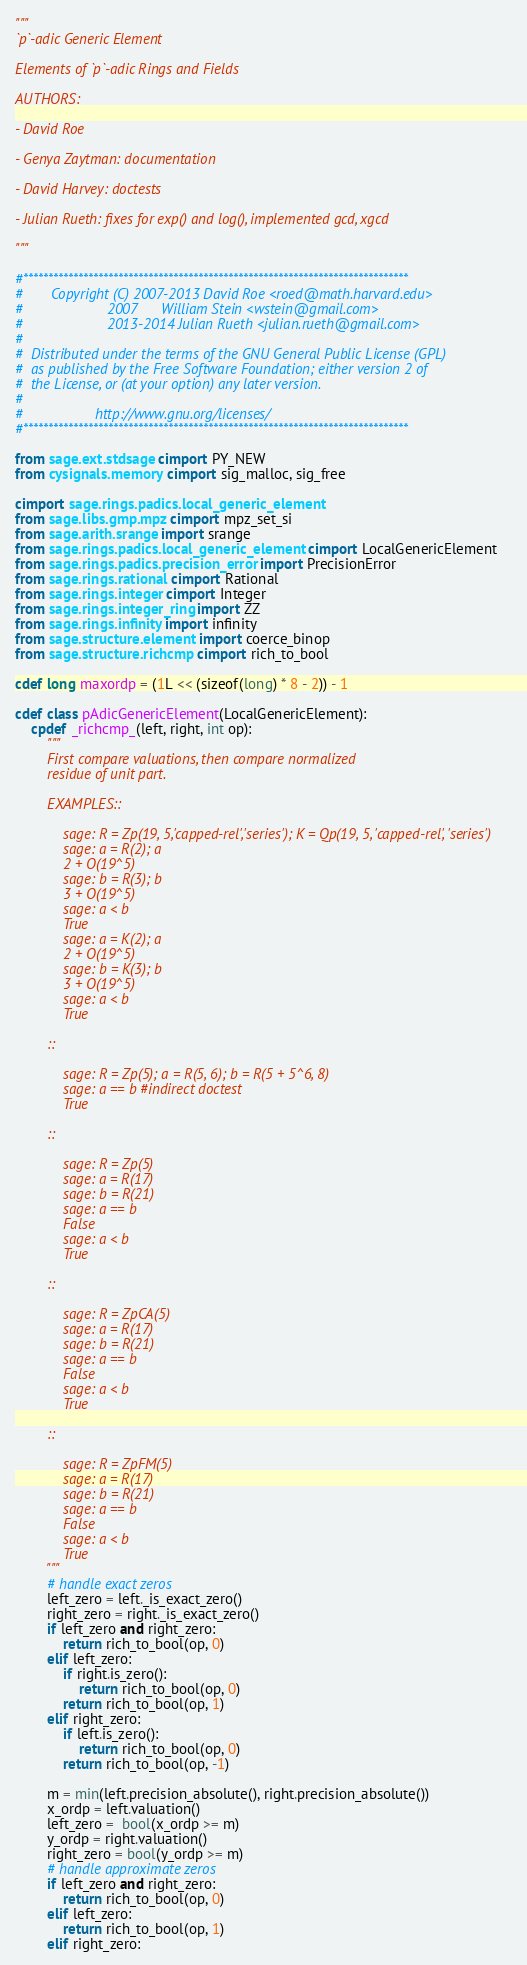<code> <loc_0><loc_0><loc_500><loc_500><_Cython_>"""
`p`-adic Generic Element

Elements of `p`-adic Rings and Fields

AUTHORS:

- David Roe

- Genya Zaytman: documentation

- David Harvey: doctests

- Julian Rueth: fixes for exp() and log(), implemented gcd, xgcd

"""

#*****************************************************************************
#       Copyright (C) 2007-2013 David Roe <roed@math.harvard.edu>
#                     2007      William Stein <wstein@gmail.com>
#                     2013-2014 Julian Rueth <julian.rueth@gmail.com>
#
#  Distributed under the terms of the GNU General Public License (GPL)
#  as published by the Free Software Foundation; either version 2 of
#  the License, or (at your option) any later version.
#
#                  http://www.gnu.org/licenses/
#*****************************************************************************

from sage.ext.stdsage cimport PY_NEW
from cysignals.memory cimport sig_malloc, sig_free

cimport sage.rings.padics.local_generic_element
from sage.libs.gmp.mpz cimport mpz_set_si
from sage.arith.srange import srange
from sage.rings.padics.local_generic_element cimport LocalGenericElement
from sage.rings.padics.precision_error import PrecisionError
from sage.rings.rational cimport Rational
from sage.rings.integer cimport Integer
from sage.rings.integer_ring import ZZ
from sage.rings.infinity import infinity
from sage.structure.element import coerce_binop
from sage.structure.richcmp cimport rich_to_bool

cdef long maxordp = (1L << (sizeof(long) * 8 - 2)) - 1

cdef class pAdicGenericElement(LocalGenericElement):
    cpdef _richcmp_(left, right, int op):
        """
        First compare valuations, then compare normalized
        residue of unit part.

        EXAMPLES::

            sage: R = Zp(19, 5,'capped-rel','series'); K = Qp(19, 5, 'capped-rel', 'series')
            sage: a = R(2); a
            2 + O(19^5)
            sage: b = R(3); b
            3 + O(19^5)
            sage: a < b
            True
            sage: a = K(2); a
            2 + O(19^5)
            sage: b = K(3); b
            3 + O(19^5)
            sage: a < b
            True

        ::

            sage: R = Zp(5); a = R(5, 6); b = R(5 + 5^6, 8)
            sage: a == b #indirect doctest
            True

        ::

            sage: R = Zp(5)
            sage: a = R(17)
            sage: b = R(21)
            sage: a == b
            False
            sage: a < b
            True

        ::

            sage: R = ZpCA(5)
            sage: a = R(17)
            sage: b = R(21)
            sage: a == b
            False
            sage: a < b
            True

        ::

            sage: R = ZpFM(5)
            sage: a = R(17)
            sage: b = R(21)
            sage: a == b
            False
            sage: a < b
            True
        """
        # handle exact zeros
        left_zero = left._is_exact_zero()
        right_zero = right._is_exact_zero()
        if left_zero and right_zero:
            return rich_to_bool(op, 0)
        elif left_zero:
            if right.is_zero():
                return rich_to_bool(op, 0)
            return rich_to_bool(op, 1)
        elif right_zero:
            if left.is_zero():
                return rich_to_bool(op, 0)
            return rich_to_bool(op, -1)

        m = min(left.precision_absolute(), right.precision_absolute())
        x_ordp = left.valuation()
        left_zero =  bool(x_ordp >= m)
        y_ordp = right.valuation()
        right_zero = bool(y_ordp >= m)
        # handle approximate zeros
        if left_zero and right_zero:
            return rich_to_bool(op, 0)
        elif left_zero:
            return rich_to_bool(op, 1)
        elif right_zero:</code> 